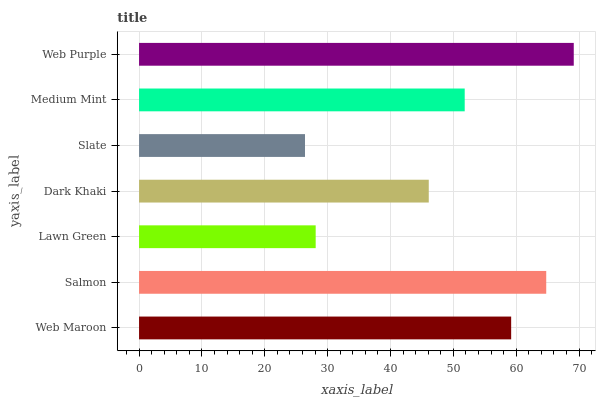Is Slate the minimum?
Answer yes or no. Yes. Is Web Purple the maximum?
Answer yes or no. Yes. Is Salmon the minimum?
Answer yes or no. No. Is Salmon the maximum?
Answer yes or no. No. Is Salmon greater than Web Maroon?
Answer yes or no. Yes. Is Web Maroon less than Salmon?
Answer yes or no. Yes. Is Web Maroon greater than Salmon?
Answer yes or no. No. Is Salmon less than Web Maroon?
Answer yes or no. No. Is Medium Mint the high median?
Answer yes or no. Yes. Is Medium Mint the low median?
Answer yes or no. Yes. Is Web Purple the high median?
Answer yes or no. No. Is Salmon the low median?
Answer yes or no. No. 